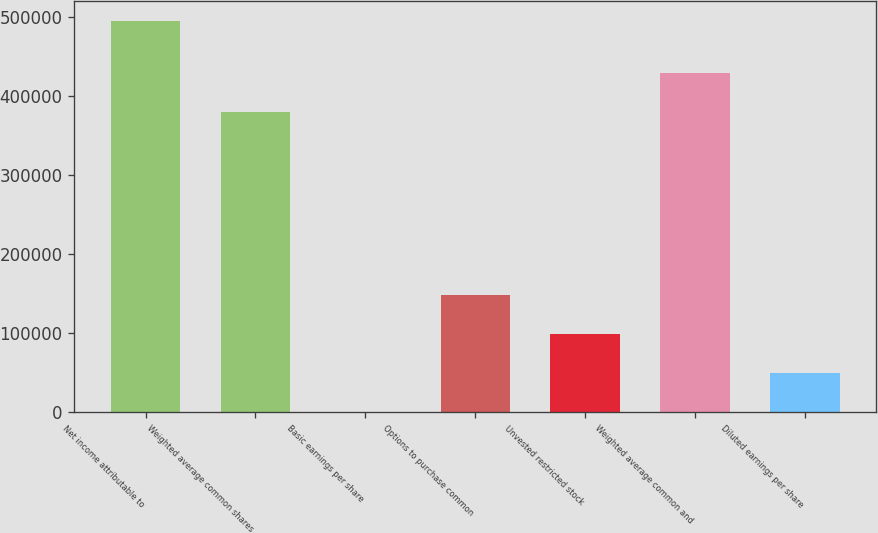Convert chart. <chart><loc_0><loc_0><loc_500><loc_500><bar_chart><fcel>Net income attributable to<fcel>Weighted average common shares<fcel>Basic earnings per share<fcel>Options to purchase common<fcel>Unvested restricted stock<fcel>Weighted average common and<fcel>Diluted earnings per share<nl><fcel>495000<fcel>379749<fcel>1.3<fcel>148501<fcel>99001<fcel>429249<fcel>49501.2<nl></chart> 